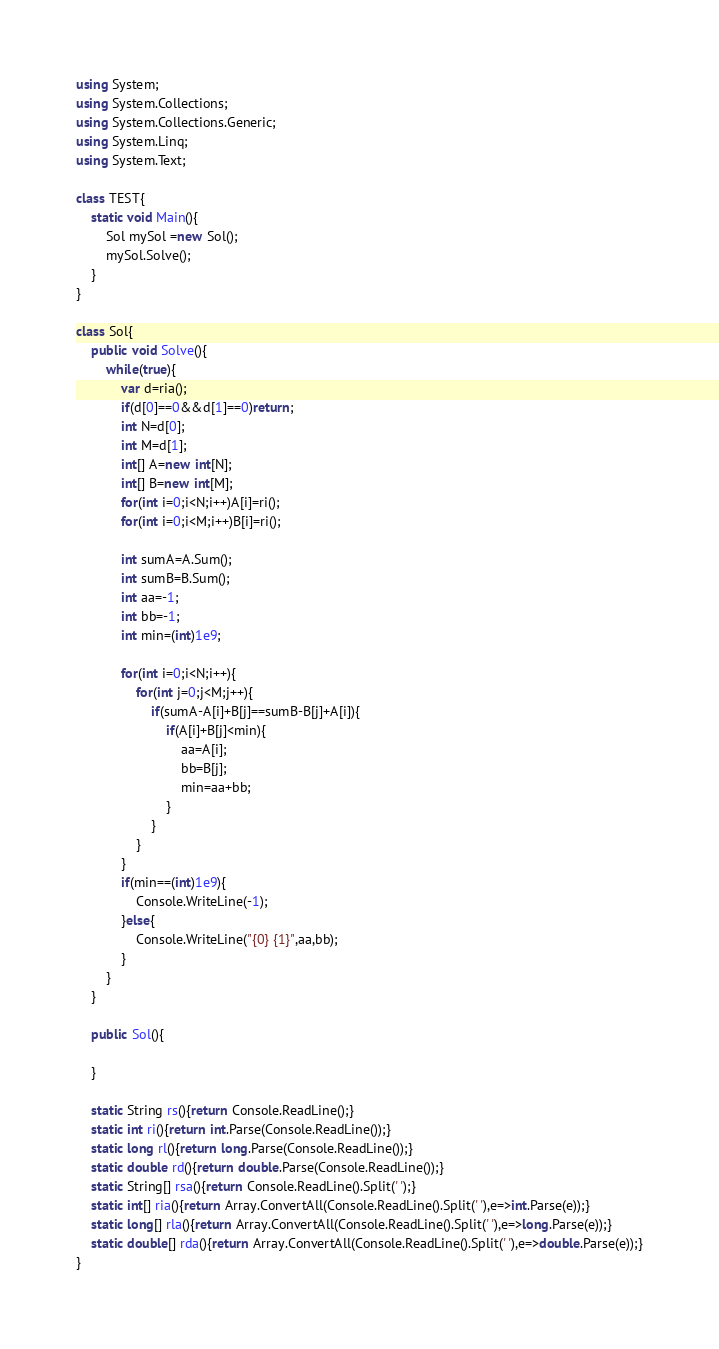Convert code to text. <code><loc_0><loc_0><loc_500><loc_500><_C#_>using System;
using System.Collections;
using System.Collections.Generic;
using System.Linq;
using System.Text;

class TEST{
	static void Main(){
		Sol mySol =new Sol();
		mySol.Solve();
	}
}

class Sol{
	public void Solve(){
		while(true){
			var d=ria();
			if(d[0]==0&&d[1]==0)return;
			int N=d[0];
			int M=d[1];
			int[] A=new int[N];
			int[] B=new int[M];
			for(int i=0;i<N;i++)A[i]=ri();
			for(int i=0;i<M;i++)B[i]=ri();
			
			int sumA=A.Sum();
			int sumB=B.Sum();
			int aa=-1;
			int bb=-1;
			int min=(int)1e9;
			
			for(int i=0;i<N;i++){
				for(int j=0;j<M;j++){
					if(sumA-A[i]+B[j]==sumB-B[j]+A[i]){
						if(A[i]+B[j]<min){
							aa=A[i];
							bb=B[j];
							min=aa+bb;
						}
					}
				}
			}
			if(min==(int)1e9){
				Console.WriteLine(-1);
			}else{
				Console.WriteLine("{0} {1}",aa,bb);
			}
		}
	}

	public Sol(){
		
	}

	static String rs(){return Console.ReadLine();}
	static int ri(){return int.Parse(Console.ReadLine());}
	static long rl(){return long.Parse(Console.ReadLine());}
	static double rd(){return double.Parse(Console.ReadLine());}
	static String[] rsa(){return Console.ReadLine().Split(' ');}
	static int[] ria(){return Array.ConvertAll(Console.ReadLine().Split(' '),e=>int.Parse(e));}
	static long[] rla(){return Array.ConvertAll(Console.ReadLine().Split(' '),e=>long.Parse(e));}
	static double[] rda(){return Array.ConvertAll(Console.ReadLine().Split(' '),e=>double.Parse(e));}
}</code> 